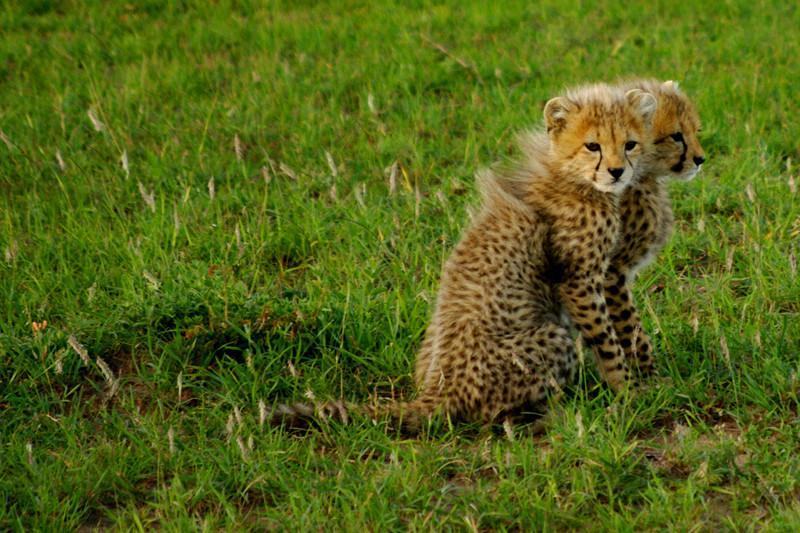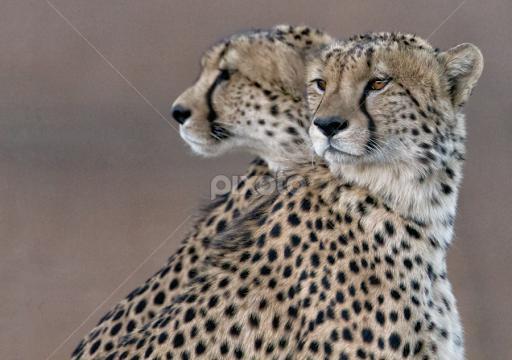The first image is the image on the left, the second image is the image on the right. Given the left and right images, does the statement "Each image shows exactly one pair of wild spotted cts with their heads overlapping." hold true? Answer yes or no. Yes. 